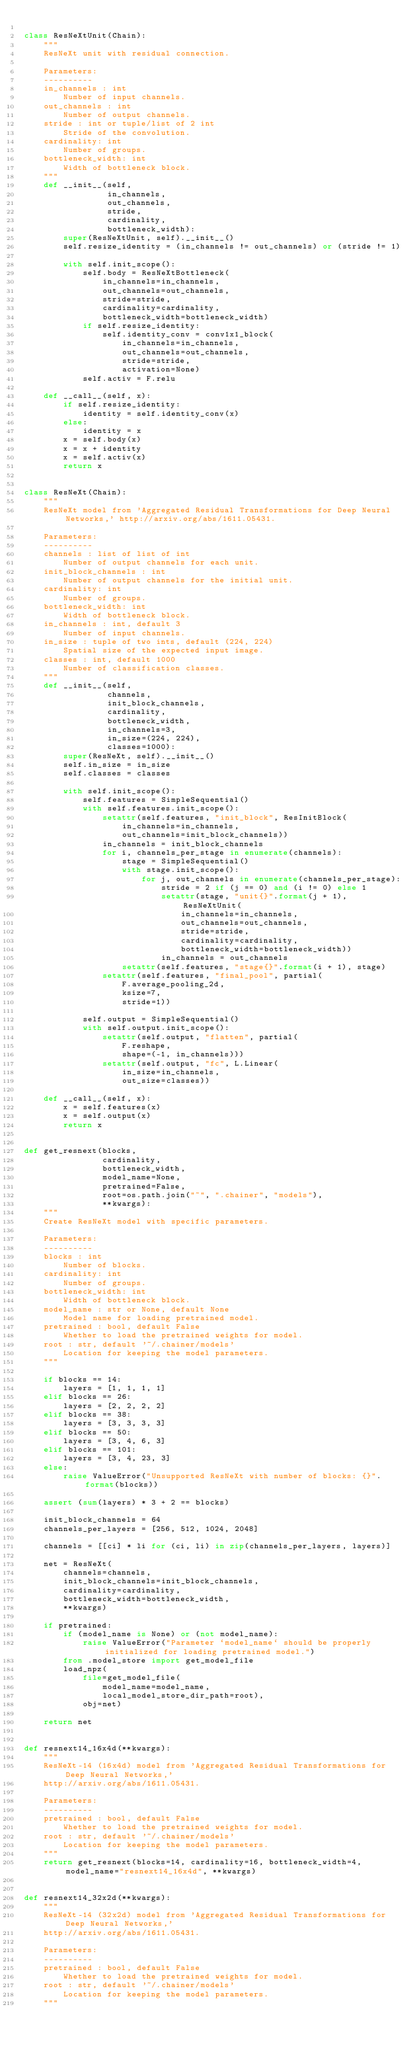Convert code to text. <code><loc_0><loc_0><loc_500><loc_500><_Python_>
class ResNeXtUnit(Chain):
    """
    ResNeXt unit with residual connection.

    Parameters:
    ----------
    in_channels : int
        Number of input channels.
    out_channels : int
        Number of output channels.
    stride : int or tuple/list of 2 int
        Stride of the convolution.
    cardinality: int
        Number of groups.
    bottleneck_width: int
        Width of bottleneck block.
    """
    def __init__(self,
                 in_channels,
                 out_channels,
                 stride,
                 cardinality,
                 bottleneck_width):
        super(ResNeXtUnit, self).__init__()
        self.resize_identity = (in_channels != out_channels) or (stride != 1)

        with self.init_scope():
            self.body = ResNeXtBottleneck(
                in_channels=in_channels,
                out_channels=out_channels,
                stride=stride,
                cardinality=cardinality,
                bottleneck_width=bottleneck_width)
            if self.resize_identity:
                self.identity_conv = conv1x1_block(
                    in_channels=in_channels,
                    out_channels=out_channels,
                    stride=stride,
                    activation=None)
            self.activ = F.relu

    def __call__(self, x):
        if self.resize_identity:
            identity = self.identity_conv(x)
        else:
            identity = x
        x = self.body(x)
        x = x + identity
        x = self.activ(x)
        return x


class ResNeXt(Chain):
    """
    ResNeXt model from 'Aggregated Residual Transformations for Deep Neural Networks,' http://arxiv.org/abs/1611.05431.

    Parameters:
    ----------
    channels : list of list of int
        Number of output channels for each unit.
    init_block_channels : int
        Number of output channels for the initial unit.
    cardinality: int
        Number of groups.
    bottleneck_width: int
        Width of bottleneck block.
    in_channels : int, default 3
        Number of input channels.
    in_size : tuple of two ints, default (224, 224)
        Spatial size of the expected input image.
    classes : int, default 1000
        Number of classification classes.
    """
    def __init__(self,
                 channels,
                 init_block_channels,
                 cardinality,
                 bottleneck_width,
                 in_channels=3,
                 in_size=(224, 224),
                 classes=1000):
        super(ResNeXt, self).__init__()
        self.in_size = in_size
        self.classes = classes

        with self.init_scope():
            self.features = SimpleSequential()
            with self.features.init_scope():
                setattr(self.features, "init_block", ResInitBlock(
                    in_channels=in_channels,
                    out_channels=init_block_channels))
                in_channels = init_block_channels
                for i, channels_per_stage in enumerate(channels):
                    stage = SimpleSequential()
                    with stage.init_scope():
                        for j, out_channels in enumerate(channels_per_stage):
                            stride = 2 if (j == 0) and (i != 0) else 1
                            setattr(stage, "unit{}".format(j + 1), ResNeXtUnit(
                                in_channels=in_channels,
                                out_channels=out_channels,
                                stride=stride,
                                cardinality=cardinality,
                                bottleneck_width=bottleneck_width))
                            in_channels = out_channels
                    setattr(self.features, "stage{}".format(i + 1), stage)
                setattr(self.features, "final_pool", partial(
                    F.average_pooling_2d,
                    ksize=7,
                    stride=1))

            self.output = SimpleSequential()
            with self.output.init_scope():
                setattr(self.output, "flatten", partial(
                    F.reshape,
                    shape=(-1, in_channels)))
                setattr(self.output, "fc", L.Linear(
                    in_size=in_channels,
                    out_size=classes))

    def __call__(self, x):
        x = self.features(x)
        x = self.output(x)
        return x


def get_resnext(blocks,
                cardinality,
                bottleneck_width,
                model_name=None,
                pretrained=False,
                root=os.path.join("~", ".chainer", "models"),
                **kwargs):
    """
    Create ResNeXt model with specific parameters.

    Parameters:
    ----------
    blocks : int
        Number of blocks.
    cardinality: int
        Number of groups.
    bottleneck_width: int
        Width of bottleneck block.
    model_name : str or None, default None
        Model name for loading pretrained model.
    pretrained : bool, default False
        Whether to load the pretrained weights for model.
    root : str, default '~/.chainer/models'
        Location for keeping the model parameters.
    """

    if blocks == 14:
        layers = [1, 1, 1, 1]
    elif blocks == 26:
        layers = [2, 2, 2, 2]
    elif blocks == 38:
        layers = [3, 3, 3, 3]
    elif blocks == 50:
        layers = [3, 4, 6, 3]
    elif blocks == 101:
        layers = [3, 4, 23, 3]
    else:
        raise ValueError("Unsupported ResNeXt with number of blocks: {}".format(blocks))

    assert (sum(layers) * 3 + 2 == blocks)

    init_block_channels = 64
    channels_per_layers = [256, 512, 1024, 2048]

    channels = [[ci] * li for (ci, li) in zip(channels_per_layers, layers)]

    net = ResNeXt(
        channels=channels,
        init_block_channels=init_block_channels,
        cardinality=cardinality,
        bottleneck_width=bottleneck_width,
        **kwargs)

    if pretrained:
        if (model_name is None) or (not model_name):
            raise ValueError("Parameter `model_name` should be properly initialized for loading pretrained model.")
        from .model_store import get_model_file
        load_npz(
            file=get_model_file(
                model_name=model_name,
                local_model_store_dir_path=root),
            obj=net)

    return net


def resnext14_16x4d(**kwargs):
    """
    ResNeXt-14 (16x4d) model from 'Aggregated Residual Transformations for Deep Neural Networks,'
    http://arxiv.org/abs/1611.05431.

    Parameters:
    ----------
    pretrained : bool, default False
        Whether to load the pretrained weights for model.
    root : str, default '~/.chainer/models'
        Location for keeping the model parameters.
    """
    return get_resnext(blocks=14, cardinality=16, bottleneck_width=4, model_name="resnext14_16x4d", **kwargs)


def resnext14_32x2d(**kwargs):
    """
    ResNeXt-14 (32x2d) model from 'Aggregated Residual Transformations for Deep Neural Networks,'
    http://arxiv.org/abs/1611.05431.

    Parameters:
    ----------
    pretrained : bool, default False
        Whether to load the pretrained weights for model.
    root : str, default '~/.chainer/models'
        Location for keeping the model parameters.
    """</code> 